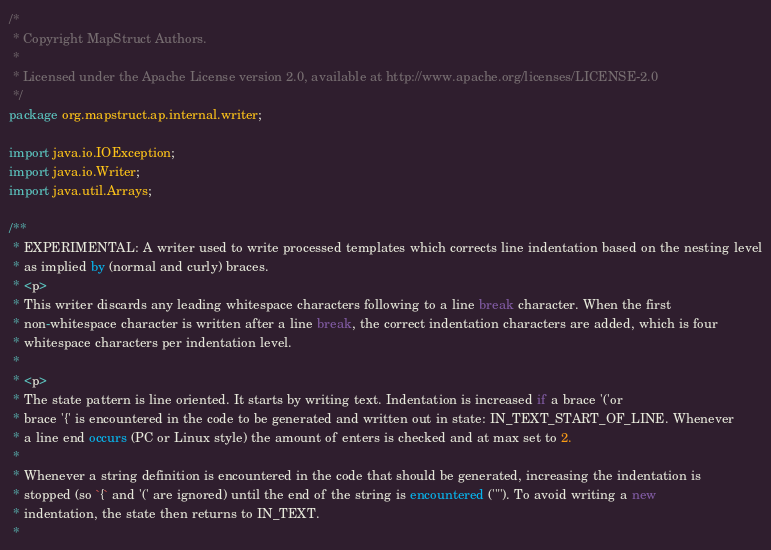Convert code to text. <code><loc_0><loc_0><loc_500><loc_500><_Java_>/*
 * Copyright MapStruct Authors.
 *
 * Licensed under the Apache License version 2.0, available at http://www.apache.org/licenses/LICENSE-2.0
 */
package org.mapstruct.ap.internal.writer;

import java.io.IOException;
import java.io.Writer;
import java.util.Arrays;

/**
 * EXPERIMENTAL: A writer used to write processed templates which corrects line indentation based on the nesting level
 * as implied by (normal and curly) braces.
 * <p>
 * This writer discards any leading whitespace characters following to a line break character. When the first
 * non-whitespace character is written after a line break, the correct indentation characters are added, which is four
 * whitespace characters per indentation level.
 *
 * <p>
 * The state pattern is line oriented. It starts by writing text. Indentation is increased if a brace '('or
 * brace '{' is encountered in the code to be generated and written out in state: IN_TEXT_START_OF_LINE. Whenever
 * a line end occurs (PC or Linux style) the amount of enters is checked and at max set to 2.
 *
 * Whenever a string definition is encountered in the code that should be generated, increasing the indentation is
 * stopped (so `{` and '(' are ignored) until the end of the string is encountered ('"'). To avoid writing a new
 * indentation, the state then returns to IN_TEXT.
 *</code> 